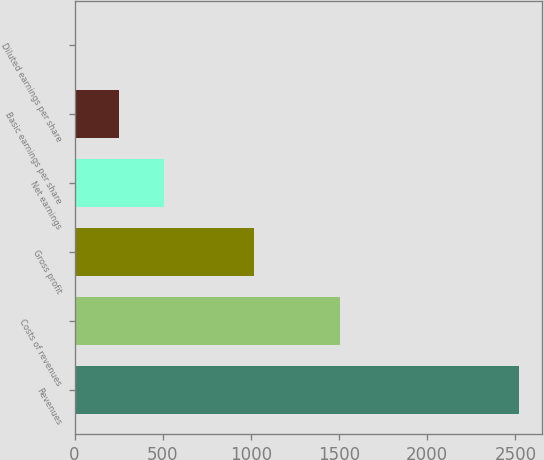<chart> <loc_0><loc_0><loc_500><loc_500><bar_chart><fcel>Revenues<fcel>Costs of revenues<fcel>Gross profit<fcel>Net earnings<fcel>Basic earnings per share<fcel>Diluted earnings per share<nl><fcel>2522.5<fcel>1506.1<fcel>1016.4<fcel>504.99<fcel>252.8<fcel>0.61<nl></chart> 